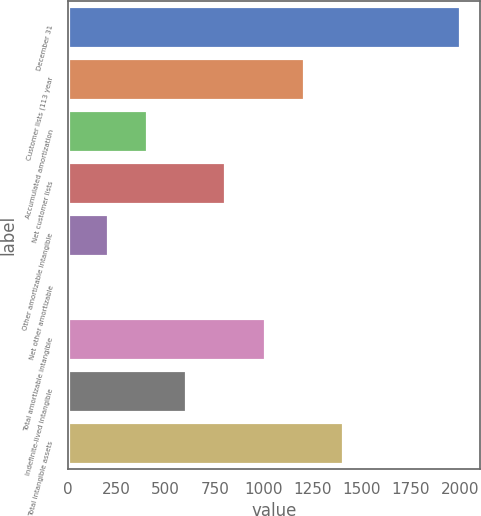<chart> <loc_0><loc_0><loc_500><loc_500><bar_chart><fcel>December 31<fcel>Customer lists (113 year<fcel>Accumulated amortization<fcel>Net customer lists<fcel>Other amortizable intangible<fcel>Net other amortizable<fcel>Total amortizable intangible<fcel>Indefinite-lived intangible<fcel>Total intangible assets<nl><fcel>2003<fcel>1203.68<fcel>404.36<fcel>804.02<fcel>204.53<fcel>4.7<fcel>1003.85<fcel>604.19<fcel>1403.51<nl></chart> 